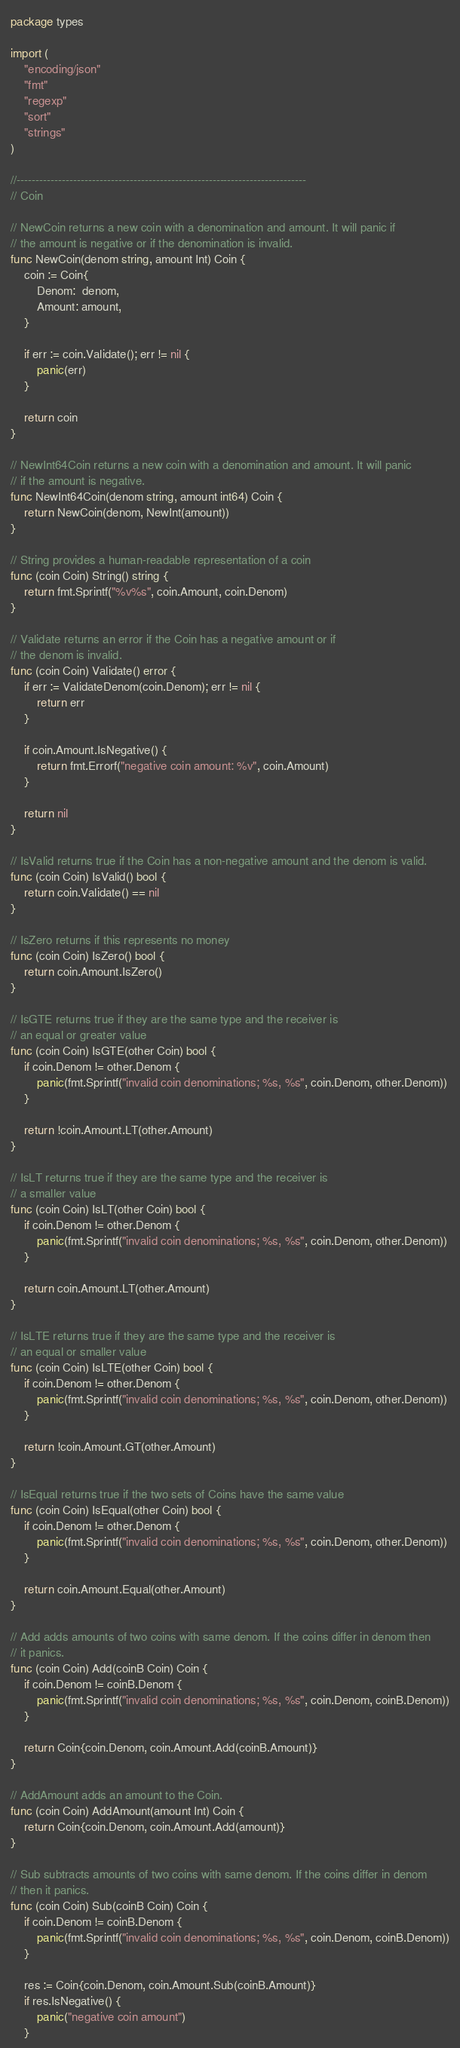<code> <loc_0><loc_0><loc_500><loc_500><_Go_>package types

import (
	"encoding/json"
	"fmt"
	"regexp"
	"sort"
	"strings"
)

//-----------------------------------------------------------------------------
// Coin

// NewCoin returns a new coin with a denomination and amount. It will panic if
// the amount is negative or if the denomination is invalid.
func NewCoin(denom string, amount Int) Coin {
	coin := Coin{
		Denom:  denom,
		Amount: amount,
	}

	if err := coin.Validate(); err != nil {
		panic(err)
	}

	return coin
}

// NewInt64Coin returns a new coin with a denomination and amount. It will panic
// if the amount is negative.
func NewInt64Coin(denom string, amount int64) Coin {
	return NewCoin(denom, NewInt(amount))
}

// String provides a human-readable representation of a coin
func (coin Coin) String() string {
	return fmt.Sprintf("%v%s", coin.Amount, coin.Denom)
}

// Validate returns an error if the Coin has a negative amount or if
// the denom is invalid.
func (coin Coin) Validate() error {
	if err := ValidateDenom(coin.Denom); err != nil {
		return err
	}

	if coin.Amount.IsNegative() {
		return fmt.Errorf("negative coin amount: %v", coin.Amount)
	}

	return nil
}

// IsValid returns true if the Coin has a non-negative amount and the denom is valid.
func (coin Coin) IsValid() bool {
	return coin.Validate() == nil
}

// IsZero returns if this represents no money
func (coin Coin) IsZero() bool {
	return coin.Amount.IsZero()
}

// IsGTE returns true if they are the same type and the receiver is
// an equal or greater value
func (coin Coin) IsGTE(other Coin) bool {
	if coin.Denom != other.Denom {
		panic(fmt.Sprintf("invalid coin denominations; %s, %s", coin.Denom, other.Denom))
	}

	return !coin.Amount.LT(other.Amount)
}

// IsLT returns true if they are the same type and the receiver is
// a smaller value
func (coin Coin) IsLT(other Coin) bool {
	if coin.Denom != other.Denom {
		panic(fmt.Sprintf("invalid coin denominations; %s, %s", coin.Denom, other.Denom))
	}

	return coin.Amount.LT(other.Amount)
}

// IsLTE returns true if they are the same type and the receiver is
// an equal or smaller value
func (coin Coin) IsLTE(other Coin) bool {
	if coin.Denom != other.Denom {
		panic(fmt.Sprintf("invalid coin denominations; %s, %s", coin.Denom, other.Denom))
	}

	return !coin.Amount.GT(other.Amount)
}

// IsEqual returns true if the two sets of Coins have the same value
func (coin Coin) IsEqual(other Coin) bool {
	if coin.Denom != other.Denom {
		panic(fmt.Sprintf("invalid coin denominations; %s, %s", coin.Denom, other.Denom))
	}

	return coin.Amount.Equal(other.Amount)
}

// Add adds amounts of two coins with same denom. If the coins differ in denom then
// it panics.
func (coin Coin) Add(coinB Coin) Coin {
	if coin.Denom != coinB.Denom {
		panic(fmt.Sprintf("invalid coin denominations; %s, %s", coin.Denom, coinB.Denom))
	}

	return Coin{coin.Denom, coin.Amount.Add(coinB.Amount)}
}

// AddAmount adds an amount to the Coin.
func (coin Coin) AddAmount(amount Int) Coin {
	return Coin{coin.Denom, coin.Amount.Add(amount)}
}

// Sub subtracts amounts of two coins with same denom. If the coins differ in denom
// then it panics.
func (coin Coin) Sub(coinB Coin) Coin {
	if coin.Denom != coinB.Denom {
		panic(fmt.Sprintf("invalid coin denominations; %s, %s", coin.Denom, coinB.Denom))
	}

	res := Coin{coin.Denom, coin.Amount.Sub(coinB.Amount)}
	if res.IsNegative() {
		panic("negative coin amount")
	}
</code> 